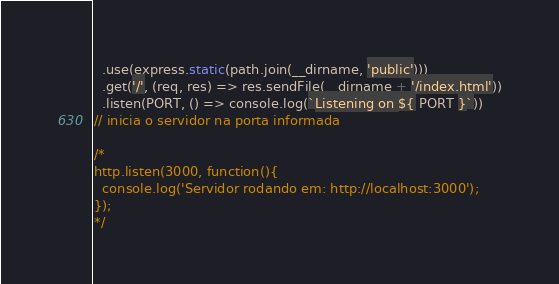Convert code to text. <code><loc_0><loc_0><loc_500><loc_500><_JavaScript_>  .use(express.static(path.join(__dirname, 'public')))
  .get('/', (req, res) => res.sendFile(__dirname + '/index.html'))
  .listen(PORT, () => console.log(`Listening on ${ PORT }`))
// inicia o servidor na porta informada

/*
http.listen(3000, function(){
  console.log('Servidor rodando em: http://localhost:3000');
});
*/
</code> 